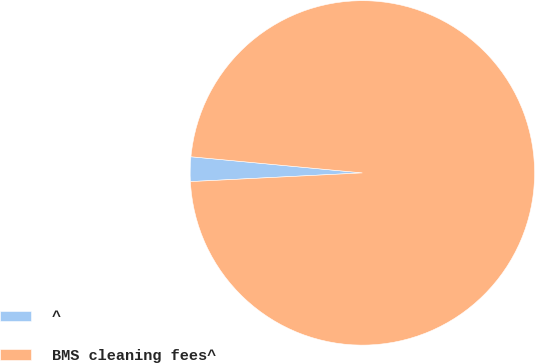<chart> <loc_0><loc_0><loc_500><loc_500><pie_chart><fcel>^<fcel>BMS cleaning fees^<nl><fcel>2.3%<fcel>97.7%<nl></chart> 